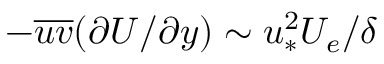Convert formula to latex. <formula><loc_0><loc_0><loc_500><loc_500>- \overline { u v } ( \partial U / \partial y ) \sim u _ { * } ^ { 2 } U _ { e } / \delta</formula> 